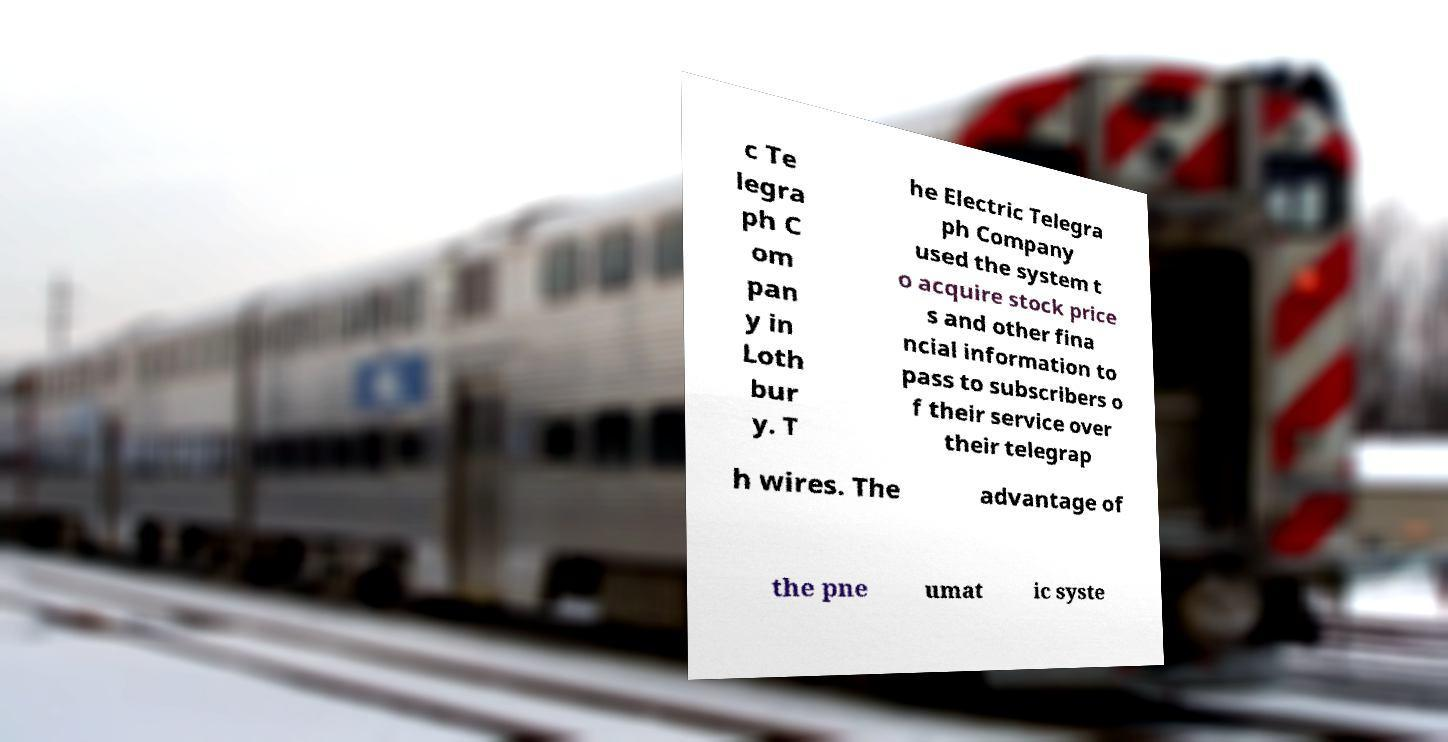Could you assist in decoding the text presented in this image and type it out clearly? c Te legra ph C om pan y in Loth bur y. T he Electric Telegra ph Company used the system t o acquire stock price s and other fina ncial information to pass to subscribers o f their service over their telegrap h wires. The advantage of the pne umat ic syste 